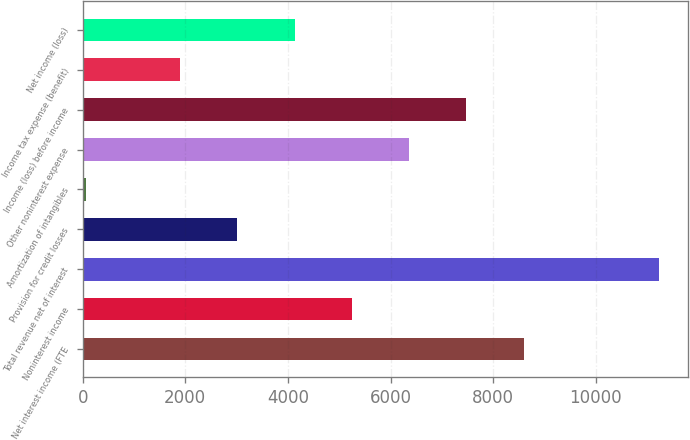Convert chart to OTSL. <chart><loc_0><loc_0><loc_500><loc_500><bar_chart><fcel>Net interest income (FTE<fcel>Noninterest income<fcel>Total revenue net of interest<fcel>Provision for credit losses<fcel>Amortization of intangibles<fcel>Other noninterest expense<fcel>Income (loss) before income<fcel>Income tax expense (benefit)<fcel>Net income (loss)<nl><fcel>8591.4<fcel>5245.2<fcel>11226<fcel>3014.4<fcel>72<fcel>6360.6<fcel>7476<fcel>1899<fcel>4129.8<nl></chart> 